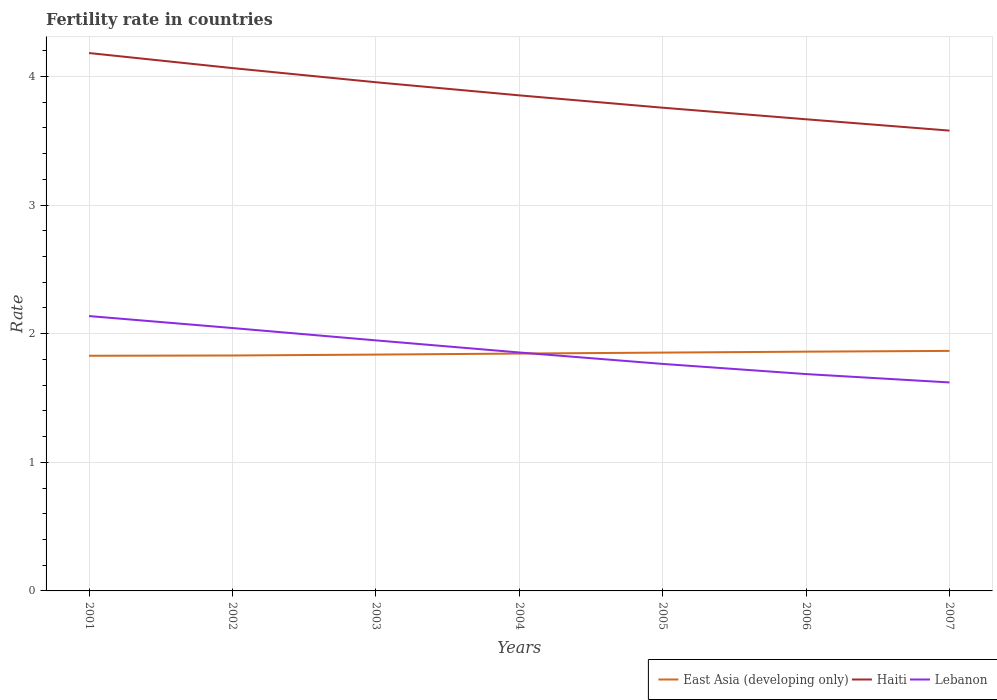How many different coloured lines are there?
Ensure brevity in your answer.  3. Does the line corresponding to East Asia (developing only) intersect with the line corresponding to Haiti?
Your answer should be compact. No. Is the number of lines equal to the number of legend labels?
Your response must be concise. Yes. Across all years, what is the maximum fertility rate in Haiti?
Your answer should be very brief. 3.58. In which year was the fertility rate in Haiti maximum?
Keep it short and to the point. 2007. What is the total fertility rate in East Asia (developing only) in the graph?
Offer a very short reply. -0.02. What is the difference between the highest and the second highest fertility rate in East Asia (developing only)?
Ensure brevity in your answer.  0.04. Is the fertility rate in East Asia (developing only) strictly greater than the fertility rate in Haiti over the years?
Offer a very short reply. Yes. How many lines are there?
Offer a very short reply. 3. Are the values on the major ticks of Y-axis written in scientific E-notation?
Your answer should be very brief. No. How are the legend labels stacked?
Offer a terse response. Horizontal. What is the title of the graph?
Offer a very short reply. Fertility rate in countries. What is the label or title of the Y-axis?
Give a very brief answer. Rate. What is the Rate of East Asia (developing only) in 2001?
Keep it short and to the point. 1.83. What is the Rate of Haiti in 2001?
Make the answer very short. 4.18. What is the Rate of Lebanon in 2001?
Provide a succinct answer. 2.14. What is the Rate of East Asia (developing only) in 2002?
Your answer should be very brief. 1.83. What is the Rate of Haiti in 2002?
Keep it short and to the point. 4.07. What is the Rate in Lebanon in 2002?
Keep it short and to the point. 2.04. What is the Rate of East Asia (developing only) in 2003?
Your response must be concise. 1.84. What is the Rate of Haiti in 2003?
Ensure brevity in your answer.  3.96. What is the Rate in Lebanon in 2003?
Make the answer very short. 1.95. What is the Rate of East Asia (developing only) in 2004?
Offer a terse response. 1.85. What is the Rate in Haiti in 2004?
Offer a terse response. 3.85. What is the Rate in Lebanon in 2004?
Provide a succinct answer. 1.85. What is the Rate in East Asia (developing only) in 2005?
Give a very brief answer. 1.85. What is the Rate of Haiti in 2005?
Offer a terse response. 3.76. What is the Rate in Lebanon in 2005?
Ensure brevity in your answer.  1.76. What is the Rate in East Asia (developing only) in 2006?
Keep it short and to the point. 1.86. What is the Rate in Haiti in 2006?
Your answer should be compact. 3.67. What is the Rate in Lebanon in 2006?
Give a very brief answer. 1.69. What is the Rate of East Asia (developing only) in 2007?
Offer a terse response. 1.87. What is the Rate in Haiti in 2007?
Keep it short and to the point. 3.58. What is the Rate in Lebanon in 2007?
Your answer should be compact. 1.62. Across all years, what is the maximum Rate of East Asia (developing only)?
Offer a very short reply. 1.87. Across all years, what is the maximum Rate in Haiti?
Provide a short and direct response. 4.18. Across all years, what is the maximum Rate of Lebanon?
Offer a very short reply. 2.14. Across all years, what is the minimum Rate in East Asia (developing only)?
Offer a terse response. 1.83. Across all years, what is the minimum Rate of Haiti?
Your answer should be compact. 3.58. Across all years, what is the minimum Rate in Lebanon?
Ensure brevity in your answer.  1.62. What is the total Rate of East Asia (developing only) in the graph?
Give a very brief answer. 12.92. What is the total Rate of Haiti in the graph?
Your response must be concise. 27.06. What is the total Rate of Lebanon in the graph?
Offer a terse response. 13.05. What is the difference between the Rate of East Asia (developing only) in 2001 and that in 2002?
Keep it short and to the point. -0. What is the difference between the Rate of Haiti in 2001 and that in 2002?
Your answer should be compact. 0.12. What is the difference between the Rate in Lebanon in 2001 and that in 2002?
Offer a terse response. 0.09. What is the difference between the Rate of East Asia (developing only) in 2001 and that in 2003?
Offer a very short reply. -0.01. What is the difference between the Rate of Haiti in 2001 and that in 2003?
Offer a terse response. 0.23. What is the difference between the Rate of Lebanon in 2001 and that in 2003?
Your response must be concise. 0.19. What is the difference between the Rate of East Asia (developing only) in 2001 and that in 2004?
Your answer should be compact. -0.02. What is the difference between the Rate in Haiti in 2001 and that in 2004?
Your answer should be very brief. 0.33. What is the difference between the Rate of Lebanon in 2001 and that in 2004?
Offer a very short reply. 0.28. What is the difference between the Rate of East Asia (developing only) in 2001 and that in 2005?
Make the answer very short. -0.02. What is the difference between the Rate in Haiti in 2001 and that in 2005?
Give a very brief answer. 0.42. What is the difference between the Rate in Lebanon in 2001 and that in 2005?
Offer a very short reply. 0.37. What is the difference between the Rate of East Asia (developing only) in 2001 and that in 2006?
Give a very brief answer. -0.03. What is the difference between the Rate of Haiti in 2001 and that in 2006?
Offer a very short reply. 0.52. What is the difference between the Rate in Lebanon in 2001 and that in 2006?
Make the answer very short. 0.45. What is the difference between the Rate in East Asia (developing only) in 2001 and that in 2007?
Offer a terse response. -0.04. What is the difference between the Rate in Haiti in 2001 and that in 2007?
Give a very brief answer. 0.6. What is the difference between the Rate of Lebanon in 2001 and that in 2007?
Your response must be concise. 0.52. What is the difference between the Rate of East Asia (developing only) in 2002 and that in 2003?
Keep it short and to the point. -0.01. What is the difference between the Rate of Haiti in 2002 and that in 2003?
Offer a very short reply. 0.11. What is the difference between the Rate in Lebanon in 2002 and that in 2003?
Ensure brevity in your answer.  0.1. What is the difference between the Rate in East Asia (developing only) in 2002 and that in 2004?
Offer a very short reply. -0.01. What is the difference between the Rate in Haiti in 2002 and that in 2004?
Give a very brief answer. 0.21. What is the difference between the Rate in Lebanon in 2002 and that in 2004?
Offer a very short reply. 0.19. What is the difference between the Rate of East Asia (developing only) in 2002 and that in 2005?
Your answer should be very brief. -0.02. What is the difference between the Rate in Haiti in 2002 and that in 2005?
Offer a very short reply. 0.31. What is the difference between the Rate of Lebanon in 2002 and that in 2005?
Your answer should be compact. 0.28. What is the difference between the Rate in East Asia (developing only) in 2002 and that in 2006?
Ensure brevity in your answer.  -0.03. What is the difference between the Rate in Haiti in 2002 and that in 2006?
Your answer should be compact. 0.4. What is the difference between the Rate in Lebanon in 2002 and that in 2006?
Your response must be concise. 0.36. What is the difference between the Rate in East Asia (developing only) in 2002 and that in 2007?
Your answer should be compact. -0.04. What is the difference between the Rate of Haiti in 2002 and that in 2007?
Provide a short and direct response. 0.49. What is the difference between the Rate of Lebanon in 2002 and that in 2007?
Make the answer very short. 0.42. What is the difference between the Rate of East Asia (developing only) in 2003 and that in 2004?
Offer a terse response. -0.01. What is the difference between the Rate of Haiti in 2003 and that in 2004?
Keep it short and to the point. 0.1. What is the difference between the Rate in Lebanon in 2003 and that in 2004?
Keep it short and to the point. 0.09. What is the difference between the Rate in East Asia (developing only) in 2003 and that in 2005?
Offer a very short reply. -0.02. What is the difference between the Rate in Haiti in 2003 and that in 2005?
Ensure brevity in your answer.  0.2. What is the difference between the Rate of Lebanon in 2003 and that in 2005?
Give a very brief answer. 0.18. What is the difference between the Rate in East Asia (developing only) in 2003 and that in 2006?
Offer a very short reply. -0.02. What is the difference between the Rate in Haiti in 2003 and that in 2006?
Provide a succinct answer. 0.29. What is the difference between the Rate in Lebanon in 2003 and that in 2006?
Keep it short and to the point. 0.26. What is the difference between the Rate in East Asia (developing only) in 2003 and that in 2007?
Offer a very short reply. -0.03. What is the difference between the Rate of Haiti in 2003 and that in 2007?
Your response must be concise. 0.38. What is the difference between the Rate of Lebanon in 2003 and that in 2007?
Your answer should be very brief. 0.33. What is the difference between the Rate of East Asia (developing only) in 2004 and that in 2005?
Give a very brief answer. -0.01. What is the difference between the Rate in Haiti in 2004 and that in 2005?
Your response must be concise. 0.1. What is the difference between the Rate of Lebanon in 2004 and that in 2005?
Your answer should be compact. 0.09. What is the difference between the Rate of East Asia (developing only) in 2004 and that in 2006?
Make the answer very short. -0.01. What is the difference between the Rate of Haiti in 2004 and that in 2006?
Offer a terse response. 0.19. What is the difference between the Rate in Lebanon in 2004 and that in 2006?
Keep it short and to the point. 0.17. What is the difference between the Rate of East Asia (developing only) in 2004 and that in 2007?
Make the answer very short. -0.02. What is the difference between the Rate of Haiti in 2004 and that in 2007?
Ensure brevity in your answer.  0.27. What is the difference between the Rate in Lebanon in 2004 and that in 2007?
Offer a very short reply. 0.23. What is the difference between the Rate of East Asia (developing only) in 2005 and that in 2006?
Make the answer very short. -0.01. What is the difference between the Rate in Haiti in 2005 and that in 2006?
Make the answer very short. 0.09. What is the difference between the Rate of Lebanon in 2005 and that in 2006?
Your response must be concise. 0.08. What is the difference between the Rate of East Asia (developing only) in 2005 and that in 2007?
Make the answer very short. -0.01. What is the difference between the Rate in Haiti in 2005 and that in 2007?
Make the answer very short. 0.18. What is the difference between the Rate in Lebanon in 2005 and that in 2007?
Your answer should be compact. 0.14. What is the difference between the Rate in East Asia (developing only) in 2006 and that in 2007?
Your answer should be very brief. -0.01. What is the difference between the Rate of Haiti in 2006 and that in 2007?
Give a very brief answer. 0.09. What is the difference between the Rate in Lebanon in 2006 and that in 2007?
Offer a terse response. 0.07. What is the difference between the Rate in East Asia (developing only) in 2001 and the Rate in Haiti in 2002?
Offer a very short reply. -2.24. What is the difference between the Rate in East Asia (developing only) in 2001 and the Rate in Lebanon in 2002?
Ensure brevity in your answer.  -0.22. What is the difference between the Rate of Haiti in 2001 and the Rate of Lebanon in 2002?
Ensure brevity in your answer.  2.14. What is the difference between the Rate of East Asia (developing only) in 2001 and the Rate of Haiti in 2003?
Give a very brief answer. -2.13. What is the difference between the Rate in East Asia (developing only) in 2001 and the Rate in Lebanon in 2003?
Offer a terse response. -0.12. What is the difference between the Rate in Haiti in 2001 and the Rate in Lebanon in 2003?
Offer a very short reply. 2.23. What is the difference between the Rate in East Asia (developing only) in 2001 and the Rate in Haiti in 2004?
Ensure brevity in your answer.  -2.02. What is the difference between the Rate in East Asia (developing only) in 2001 and the Rate in Lebanon in 2004?
Provide a succinct answer. -0.03. What is the difference between the Rate of Haiti in 2001 and the Rate of Lebanon in 2004?
Provide a short and direct response. 2.33. What is the difference between the Rate in East Asia (developing only) in 2001 and the Rate in Haiti in 2005?
Offer a very short reply. -1.93. What is the difference between the Rate of East Asia (developing only) in 2001 and the Rate of Lebanon in 2005?
Provide a short and direct response. 0.06. What is the difference between the Rate in Haiti in 2001 and the Rate in Lebanon in 2005?
Ensure brevity in your answer.  2.42. What is the difference between the Rate in East Asia (developing only) in 2001 and the Rate in Haiti in 2006?
Give a very brief answer. -1.84. What is the difference between the Rate in East Asia (developing only) in 2001 and the Rate in Lebanon in 2006?
Your answer should be compact. 0.14. What is the difference between the Rate in Haiti in 2001 and the Rate in Lebanon in 2006?
Your response must be concise. 2.5. What is the difference between the Rate in East Asia (developing only) in 2001 and the Rate in Haiti in 2007?
Your response must be concise. -1.75. What is the difference between the Rate of East Asia (developing only) in 2001 and the Rate of Lebanon in 2007?
Provide a short and direct response. 0.21. What is the difference between the Rate in Haiti in 2001 and the Rate in Lebanon in 2007?
Keep it short and to the point. 2.56. What is the difference between the Rate of East Asia (developing only) in 2002 and the Rate of Haiti in 2003?
Offer a very short reply. -2.12. What is the difference between the Rate in East Asia (developing only) in 2002 and the Rate in Lebanon in 2003?
Give a very brief answer. -0.12. What is the difference between the Rate in Haiti in 2002 and the Rate in Lebanon in 2003?
Ensure brevity in your answer.  2.12. What is the difference between the Rate in East Asia (developing only) in 2002 and the Rate in Haiti in 2004?
Your answer should be very brief. -2.02. What is the difference between the Rate of East Asia (developing only) in 2002 and the Rate of Lebanon in 2004?
Give a very brief answer. -0.02. What is the difference between the Rate of Haiti in 2002 and the Rate of Lebanon in 2004?
Provide a short and direct response. 2.21. What is the difference between the Rate of East Asia (developing only) in 2002 and the Rate of Haiti in 2005?
Make the answer very short. -1.93. What is the difference between the Rate in East Asia (developing only) in 2002 and the Rate in Lebanon in 2005?
Offer a very short reply. 0.07. What is the difference between the Rate in East Asia (developing only) in 2002 and the Rate in Haiti in 2006?
Provide a short and direct response. -1.84. What is the difference between the Rate in East Asia (developing only) in 2002 and the Rate in Lebanon in 2006?
Your answer should be very brief. 0.14. What is the difference between the Rate of Haiti in 2002 and the Rate of Lebanon in 2006?
Your response must be concise. 2.38. What is the difference between the Rate in East Asia (developing only) in 2002 and the Rate in Haiti in 2007?
Keep it short and to the point. -1.75. What is the difference between the Rate of East Asia (developing only) in 2002 and the Rate of Lebanon in 2007?
Your response must be concise. 0.21. What is the difference between the Rate in Haiti in 2002 and the Rate in Lebanon in 2007?
Give a very brief answer. 2.44. What is the difference between the Rate of East Asia (developing only) in 2003 and the Rate of Haiti in 2004?
Keep it short and to the point. -2.02. What is the difference between the Rate in East Asia (developing only) in 2003 and the Rate in Lebanon in 2004?
Offer a terse response. -0.02. What is the difference between the Rate of Haiti in 2003 and the Rate of Lebanon in 2004?
Your response must be concise. 2.1. What is the difference between the Rate in East Asia (developing only) in 2003 and the Rate in Haiti in 2005?
Your answer should be compact. -1.92. What is the difference between the Rate of East Asia (developing only) in 2003 and the Rate of Lebanon in 2005?
Provide a short and direct response. 0.07. What is the difference between the Rate in Haiti in 2003 and the Rate in Lebanon in 2005?
Your response must be concise. 2.19. What is the difference between the Rate in East Asia (developing only) in 2003 and the Rate in Haiti in 2006?
Provide a short and direct response. -1.83. What is the difference between the Rate in East Asia (developing only) in 2003 and the Rate in Lebanon in 2006?
Ensure brevity in your answer.  0.15. What is the difference between the Rate in Haiti in 2003 and the Rate in Lebanon in 2006?
Provide a short and direct response. 2.27. What is the difference between the Rate of East Asia (developing only) in 2003 and the Rate of Haiti in 2007?
Give a very brief answer. -1.74. What is the difference between the Rate in East Asia (developing only) in 2003 and the Rate in Lebanon in 2007?
Ensure brevity in your answer.  0.22. What is the difference between the Rate in Haiti in 2003 and the Rate in Lebanon in 2007?
Offer a terse response. 2.33. What is the difference between the Rate in East Asia (developing only) in 2004 and the Rate in Haiti in 2005?
Ensure brevity in your answer.  -1.91. What is the difference between the Rate in East Asia (developing only) in 2004 and the Rate in Lebanon in 2005?
Provide a succinct answer. 0.08. What is the difference between the Rate of Haiti in 2004 and the Rate of Lebanon in 2005?
Provide a short and direct response. 2.09. What is the difference between the Rate of East Asia (developing only) in 2004 and the Rate of Haiti in 2006?
Offer a terse response. -1.82. What is the difference between the Rate of East Asia (developing only) in 2004 and the Rate of Lebanon in 2006?
Your answer should be compact. 0.16. What is the difference between the Rate in Haiti in 2004 and the Rate in Lebanon in 2006?
Your answer should be compact. 2.17. What is the difference between the Rate in East Asia (developing only) in 2004 and the Rate in Haiti in 2007?
Keep it short and to the point. -1.73. What is the difference between the Rate of East Asia (developing only) in 2004 and the Rate of Lebanon in 2007?
Your answer should be very brief. 0.22. What is the difference between the Rate of Haiti in 2004 and the Rate of Lebanon in 2007?
Keep it short and to the point. 2.23. What is the difference between the Rate of East Asia (developing only) in 2005 and the Rate of Haiti in 2006?
Make the answer very short. -1.81. What is the difference between the Rate in East Asia (developing only) in 2005 and the Rate in Lebanon in 2006?
Keep it short and to the point. 0.17. What is the difference between the Rate of Haiti in 2005 and the Rate of Lebanon in 2006?
Your answer should be very brief. 2.07. What is the difference between the Rate in East Asia (developing only) in 2005 and the Rate in Haiti in 2007?
Make the answer very short. -1.73. What is the difference between the Rate in East Asia (developing only) in 2005 and the Rate in Lebanon in 2007?
Offer a terse response. 0.23. What is the difference between the Rate in Haiti in 2005 and the Rate in Lebanon in 2007?
Offer a terse response. 2.14. What is the difference between the Rate in East Asia (developing only) in 2006 and the Rate in Haiti in 2007?
Give a very brief answer. -1.72. What is the difference between the Rate in East Asia (developing only) in 2006 and the Rate in Lebanon in 2007?
Your answer should be compact. 0.24. What is the difference between the Rate in Haiti in 2006 and the Rate in Lebanon in 2007?
Provide a short and direct response. 2.05. What is the average Rate in East Asia (developing only) per year?
Your answer should be compact. 1.85. What is the average Rate of Haiti per year?
Offer a terse response. 3.87. What is the average Rate of Lebanon per year?
Your answer should be compact. 1.86. In the year 2001, what is the difference between the Rate in East Asia (developing only) and Rate in Haiti?
Provide a short and direct response. -2.35. In the year 2001, what is the difference between the Rate of East Asia (developing only) and Rate of Lebanon?
Provide a short and direct response. -0.31. In the year 2001, what is the difference between the Rate in Haiti and Rate in Lebanon?
Provide a short and direct response. 2.04. In the year 2002, what is the difference between the Rate in East Asia (developing only) and Rate in Haiti?
Keep it short and to the point. -2.23. In the year 2002, what is the difference between the Rate in East Asia (developing only) and Rate in Lebanon?
Provide a short and direct response. -0.21. In the year 2002, what is the difference between the Rate of Haiti and Rate of Lebanon?
Your response must be concise. 2.02. In the year 2003, what is the difference between the Rate in East Asia (developing only) and Rate in Haiti?
Ensure brevity in your answer.  -2.12. In the year 2003, what is the difference between the Rate in East Asia (developing only) and Rate in Lebanon?
Keep it short and to the point. -0.11. In the year 2003, what is the difference between the Rate of Haiti and Rate of Lebanon?
Your response must be concise. 2.01. In the year 2004, what is the difference between the Rate in East Asia (developing only) and Rate in Haiti?
Make the answer very short. -2.01. In the year 2004, what is the difference between the Rate in East Asia (developing only) and Rate in Lebanon?
Keep it short and to the point. -0.01. In the year 2004, what is the difference between the Rate in Haiti and Rate in Lebanon?
Your response must be concise. 2. In the year 2005, what is the difference between the Rate in East Asia (developing only) and Rate in Haiti?
Give a very brief answer. -1.9. In the year 2005, what is the difference between the Rate of East Asia (developing only) and Rate of Lebanon?
Your answer should be very brief. 0.09. In the year 2005, what is the difference between the Rate in Haiti and Rate in Lebanon?
Your answer should be compact. 1.99. In the year 2006, what is the difference between the Rate of East Asia (developing only) and Rate of Haiti?
Provide a short and direct response. -1.81. In the year 2006, what is the difference between the Rate of East Asia (developing only) and Rate of Lebanon?
Provide a short and direct response. 0.17. In the year 2006, what is the difference between the Rate in Haiti and Rate in Lebanon?
Give a very brief answer. 1.98. In the year 2007, what is the difference between the Rate of East Asia (developing only) and Rate of Haiti?
Keep it short and to the point. -1.71. In the year 2007, what is the difference between the Rate of East Asia (developing only) and Rate of Lebanon?
Provide a succinct answer. 0.25. In the year 2007, what is the difference between the Rate in Haiti and Rate in Lebanon?
Your response must be concise. 1.96. What is the ratio of the Rate of East Asia (developing only) in 2001 to that in 2002?
Provide a short and direct response. 1. What is the ratio of the Rate of Haiti in 2001 to that in 2002?
Your answer should be very brief. 1.03. What is the ratio of the Rate of Lebanon in 2001 to that in 2002?
Make the answer very short. 1.05. What is the ratio of the Rate of Haiti in 2001 to that in 2003?
Your answer should be very brief. 1.06. What is the ratio of the Rate of Lebanon in 2001 to that in 2003?
Your response must be concise. 1.1. What is the ratio of the Rate in Haiti in 2001 to that in 2004?
Your response must be concise. 1.09. What is the ratio of the Rate of Lebanon in 2001 to that in 2004?
Provide a short and direct response. 1.15. What is the ratio of the Rate of East Asia (developing only) in 2001 to that in 2005?
Ensure brevity in your answer.  0.99. What is the ratio of the Rate in Haiti in 2001 to that in 2005?
Your answer should be very brief. 1.11. What is the ratio of the Rate in Lebanon in 2001 to that in 2005?
Make the answer very short. 1.21. What is the ratio of the Rate of East Asia (developing only) in 2001 to that in 2006?
Offer a very short reply. 0.98. What is the ratio of the Rate of Haiti in 2001 to that in 2006?
Make the answer very short. 1.14. What is the ratio of the Rate of Lebanon in 2001 to that in 2006?
Offer a terse response. 1.27. What is the ratio of the Rate in East Asia (developing only) in 2001 to that in 2007?
Make the answer very short. 0.98. What is the ratio of the Rate in Haiti in 2001 to that in 2007?
Keep it short and to the point. 1.17. What is the ratio of the Rate in Lebanon in 2001 to that in 2007?
Offer a very short reply. 1.32. What is the ratio of the Rate in East Asia (developing only) in 2002 to that in 2003?
Keep it short and to the point. 1. What is the ratio of the Rate of Haiti in 2002 to that in 2003?
Your answer should be compact. 1.03. What is the ratio of the Rate of Lebanon in 2002 to that in 2003?
Your answer should be compact. 1.05. What is the ratio of the Rate of Haiti in 2002 to that in 2004?
Keep it short and to the point. 1.05. What is the ratio of the Rate of Lebanon in 2002 to that in 2004?
Keep it short and to the point. 1.1. What is the ratio of the Rate in East Asia (developing only) in 2002 to that in 2005?
Your response must be concise. 0.99. What is the ratio of the Rate in Haiti in 2002 to that in 2005?
Provide a short and direct response. 1.08. What is the ratio of the Rate in Lebanon in 2002 to that in 2005?
Your response must be concise. 1.16. What is the ratio of the Rate in East Asia (developing only) in 2002 to that in 2006?
Provide a short and direct response. 0.98. What is the ratio of the Rate in Haiti in 2002 to that in 2006?
Make the answer very short. 1.11. What is the ratio of the Rate in Lebanon in 2002 to that in 2006?
Keep it short and to the point. 1.21. What is the ratio of the Rate of East Asia (developing only) in 2002 to that in 2007?
Make the answer very short. 0.98. What is the ratio of the Rate in Haiti in 2002 to that in 2007?
Provide a short and direct response. 1.14. What is the ratio of the Rate in Lebanon in 2002 to that in 2007?
Offer a terse response. 1.26. What is the ratio of the Rate of East Asia (developing only) in 2003 to that in 2004?
Keep it short and to the point. 1. What is the ratio of the Rate of Haiti in 2003 to that in 2004?
Offer a very short reply. 1.03. What is the ratio of the Rate in Lebanon in 2003 to that in 2004?
Offer a very short reply. 1.05. What is the ratio of the Rate of Haiti in 2003 to that in 2005?
Your response must be concise. 1.05. What is the ratio of the Rate of Lebanon in 2003 to that in 2005?
Offer a terse response. 1.1. What is the ratio of the Rate of Haiti in 2003 to that in 2006?
Offer a terse response. 1.08. What is the ratio of the Rate of Lebanon in 2003 to that in 2006?
Offer a very short reply. 1.16. What is the ratio of the Rate of East Asia (developing only) in 2003 to that in 2007?
Keep it short and to the point. 0.98. What is the ratio of the Rate of Haiti in 2003 to that in 2007?
Your response must be concise. 1.11. What is the ratio of the Rate in Lebanon in 2003 to that in 2007?
Make the answer very short. 1.2. What is the ratio of the Rate of Haiti in 2004 to that in 2005?
Make the answer very short. 1.03. What is the ratio of the Rate of Lebanon in 2004 to that in 2005?
Offer a terse response. 1.05. What is the ratio of the Rate in Haiti in 2004 to that in 2006?
Your answer should be compact. 1.05. What is the ratio of the Rate in Lebanon in 2004 to that in 2006?
Your response must be concise. 1.1. What is the ratio of the Rate in East Asia (developing only) in 2004 to that in 2007?
Your response must be concise. 0.99. What is the ratio of the Rate in Haiti in 2004 to that in 2007?
Provide a succinct answer. 1.08. What is the ratio of the Rate in Lebanon in 2004 to that in 2007?
Make the answer very short. 1.14. What is the ratio of the Rate in East Asia (developing only) in 2005 to that in 2006?
Keep it short and to the point. 1. What is the ratio of the Rate of Haiti in 2005 to that in 2006?
Your response must be concise. 1.02. What is the ratio of the Rate of Lebanon in 2005 to that in 2006?
Provide a short and direct response. 1.05. What is the ratio of the Rate of Haiti in 2005 to that in 2007?
Give a very brief answer. 1.05. What is the ratio of the Rate of Lebanon in 2005 to that in 2007?
Ensure brevity in your answer.  1.09. What is the ratio of the Rate of Haiti in 2006 to that in 2007?
Give a very brief answer. 1.02. What is the ratio of the Rate of Lebanon in 2006 to that in 2007?
Your response must be concise. 1.04. What is the difference between the highest and the second highest Rate in East Asia (developing only)?
Your answer should be very brief. 0.01. What is the difference between the highest and the second highest Rate of Haiti?
Give a very brief answer. 0.12. What is the difference between the highest and the second highest Rate in Lebanon?
Provide a short and direct response. 0.09. What is the difference between the highest and the lowest Rate in East Asia (developing only)?
Keep it short and to the point. 0.04. What is the difference between the highest and the lowest Rate in Haiti?
Your response must be concise. 0.6. What is the difference between the highest and the lowest Rate of Lebanon?
Provide a succinct answer. 0.52. 